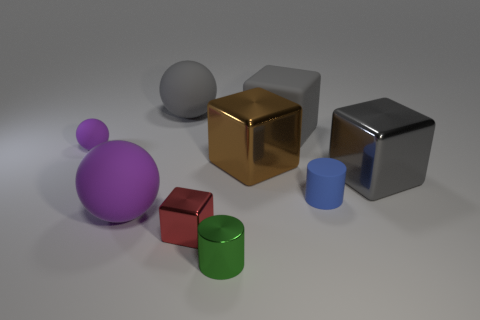Add 1 large red metal cubes. How many objects exist? 10 Subtract all spheres. How many objects are left? 6 Add 7 large gray matte things. How many large gray matte things are left? 9 Add 1 tiny purple rubber cylinders. How many tiny purple rubber cylinders exist? 1 Subtract 0 brown spheres. How many objects are left? 9 Subtract all red balls. Subtract all tiny purple spheres. How many objects are left? 8 